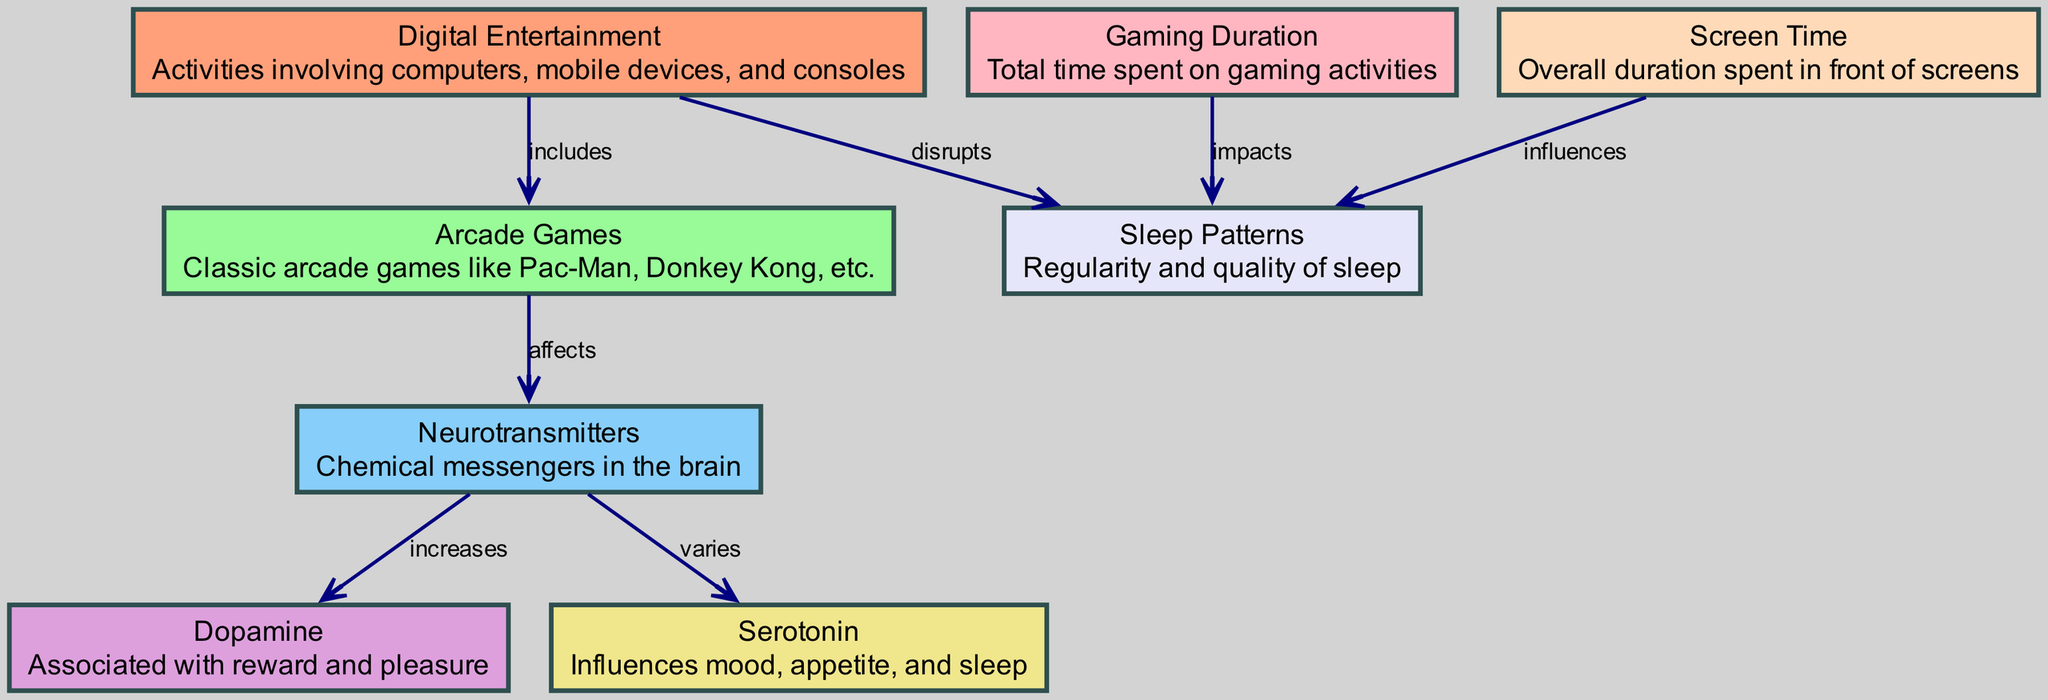What is the central focus of the diagram? The diagram focuses on the influence of digital entertainment on neurotransmitter levels and sleep patterns, exploring how these elements are interconnected.
Answer: Digital Entertainment How many nodes are present in the diagram? The diagram contains 8 nodes that represent various concepts related to digital entertainment, neurotransmitters, and their effects on sleep patterns.
Answer: 8 What is the relationship between Arcade Games and Neurotransmitters? Arcade Games affect neurotransmitters, indicating that playing arcade games has a direct impact on the levels or activities of these chemical messengers in the brain.
Answer: affects Which neurotransmitter is associated with reward and pleasure? Dopamine is highlighted in the diagram as the neurotransmitter linked to feelings of reward and pleasure, emphasizing its role in responses to activities like gaming.
Answer: Dopamine What element does Screen Time influence? Screen Time influences Sleep Patterns, suggesting that the duration spent in front of screens can affect one’s sleep quality and regularity.
Answer: Sleep Patterns What happens to Serotonin as a result of digital entertainment? Serotonin varies in response to digital entertainment, indicating fluctuations in this neurotransmitter's levels based on engagement in digital activities.
Answer: varies How does Gaming Duration impact Sleep Patterns? Gaming Duration impacts Sleep Patterns, meaning the amount of time spent on gaming activities can have a significant effect on how effectively one sleeps.
Answer: impacts Which node is primarily disrupted by Digital Entertainment? Digital Entertainment disrupts Sleep Patterns, showing a negative correlation between engaging in digital activities and the quality or regularity of sleep experienced.
Answer: Sleep Patterns What color represents Neurotransmitters in the diagram? In the diagram, Neurotransmitters are represented in light sky blue, visually distinguishing them from other elements through color coding.
Answer: Light Sky Blue 